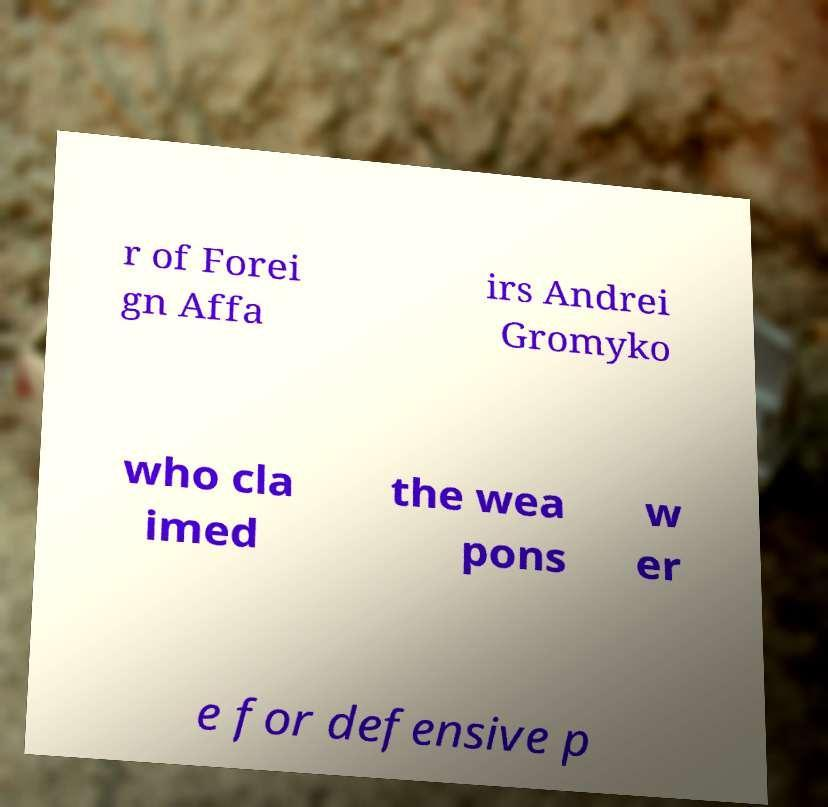For documentation purposes, I need the text within this image transcribed. Could you provide that? r of Forei gn Affa irs Andrei Gromyko who cla imed the wea pons w er e for defensive p 